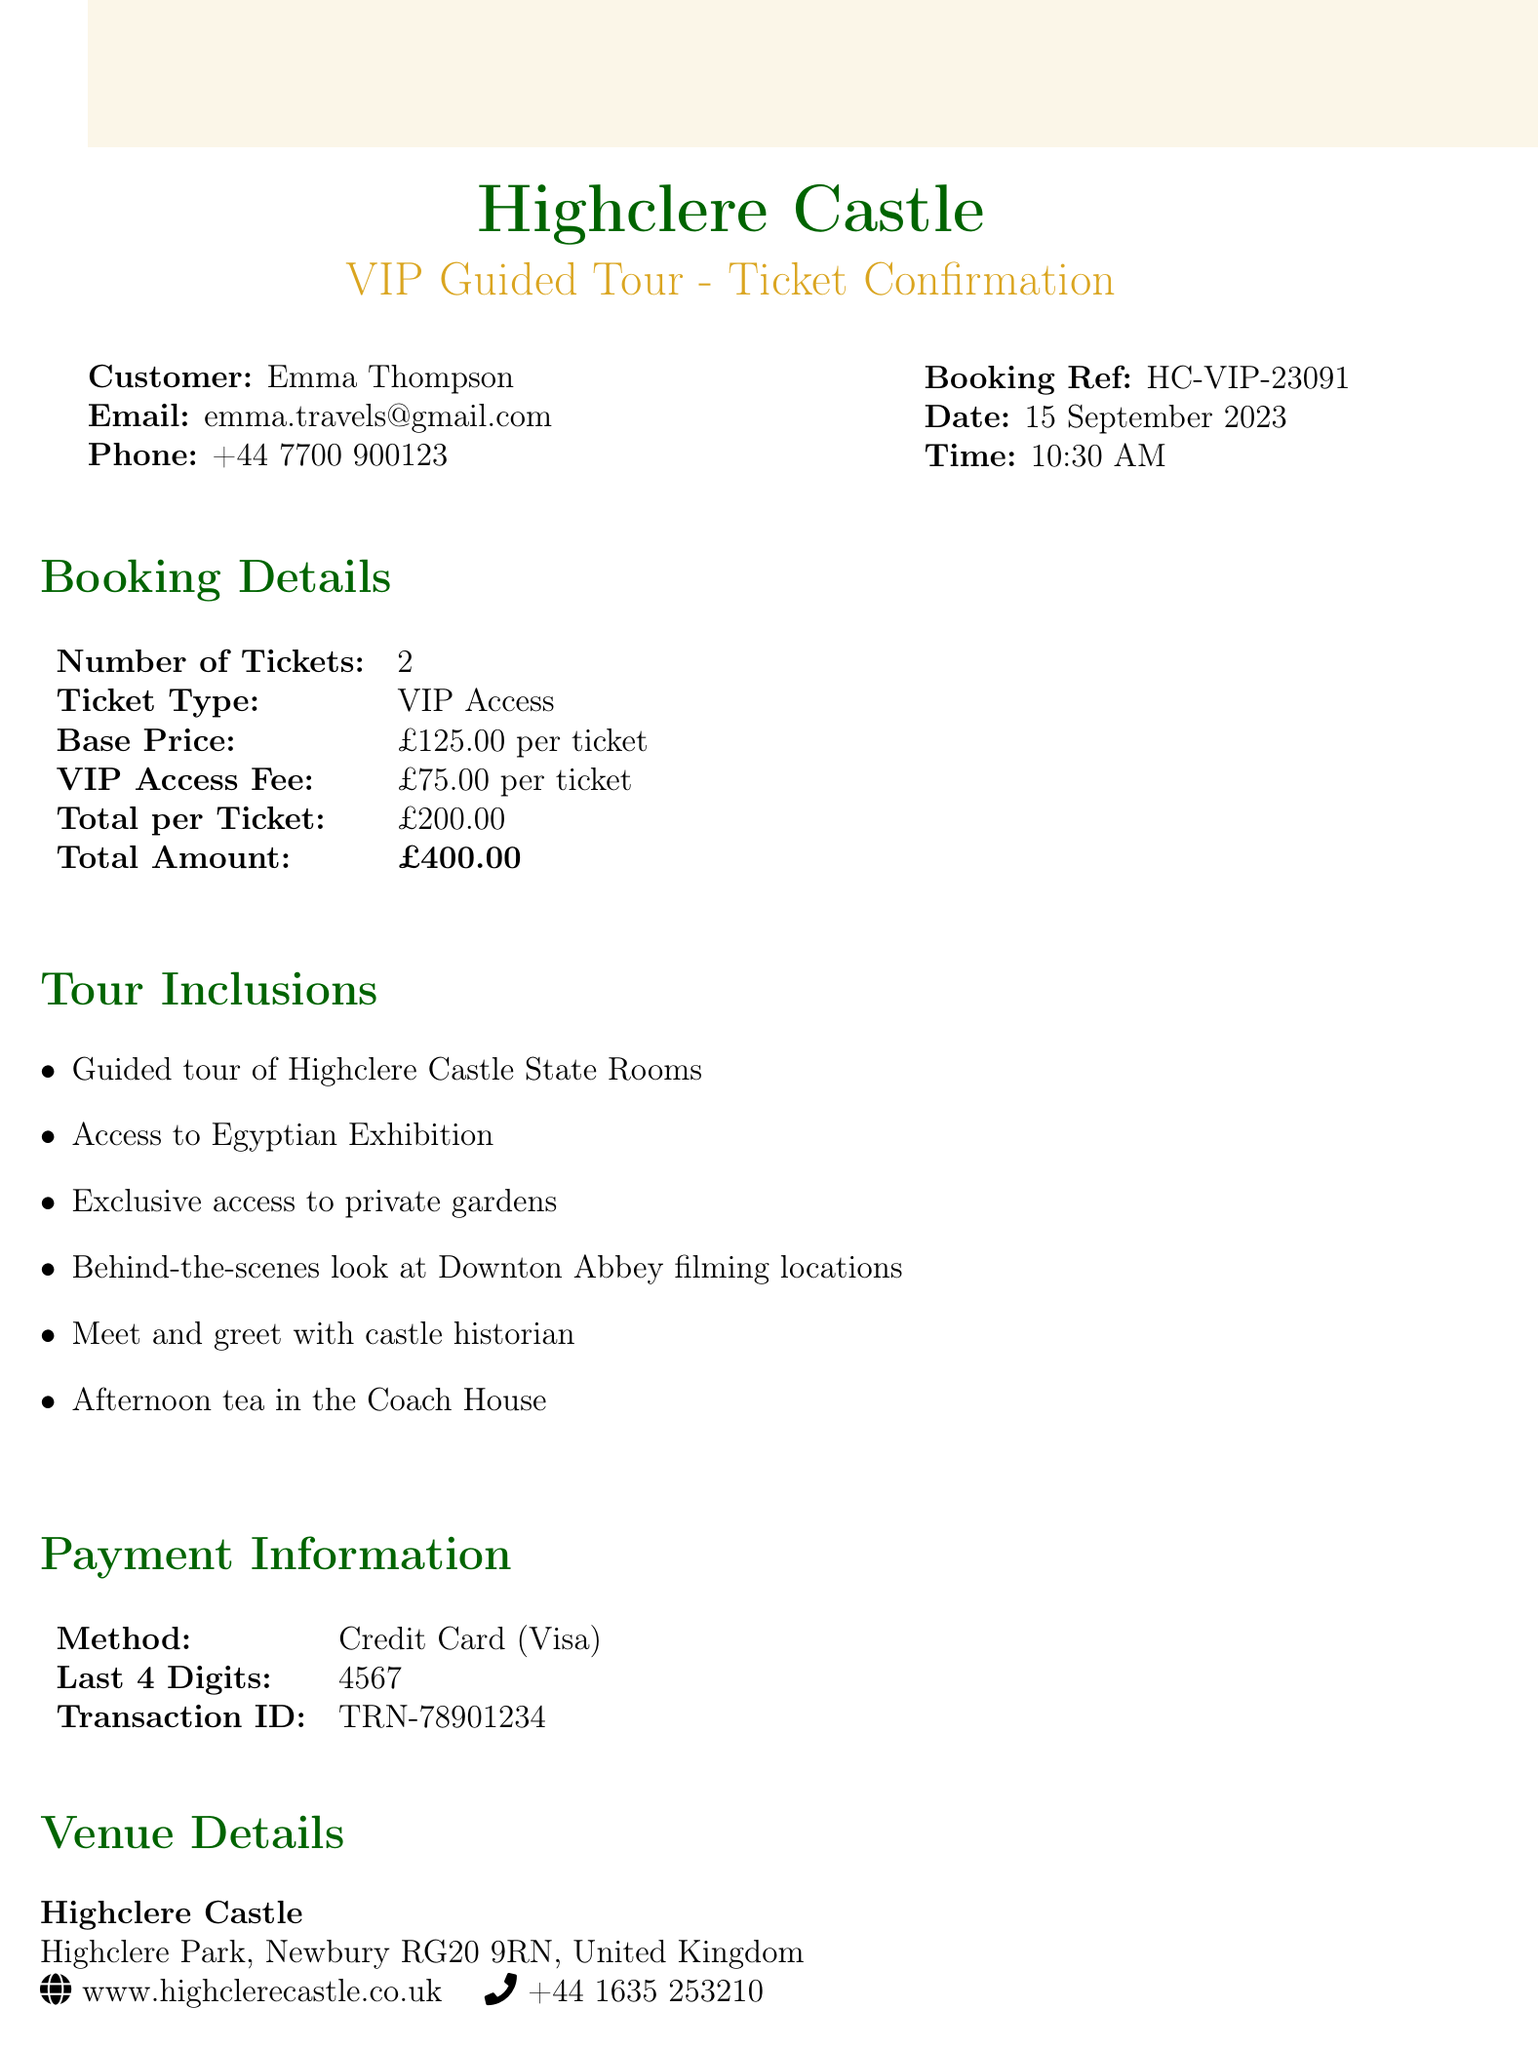What is the event name? The event name is explicitly stated in the document under the section "event_name".
Answer: Guided Tour of Highclere Castle - VIP Access What is the total amount for the tickets? The total amount is provided in the "pricing" section which sums the total costs related to the tickets.
Answer: £400.00 What is the booking reference number? The booking reference number is found in the "booking_details" section under "booking_reference".
Answer: HC-VIP-23091 How many tickets were purchased? The number of tickets is indicated in the "booking_details" section under "number_of_tickets".
Answer: 2 What is the dress code for the tour? The dress code is mentioned in the "additional_info" section highlighting required attire.
Answer: Smart casual What percentage refund is available before 7 days? The percentage is specified in the "cancellation_policy" section detailing refunds based on timing.
Answer: 50 What are the inclusions of the guided tour? The inclusions outline specific experiences offered during the tour, listed under "tour_inclusions".
Answer: Guided tour of Highclere Castle State Rooms, Access to Egyptian Exhibition, Exclusive access to private gardens, Behind-the-scenes look at Downton Abbey filming locations, Meet and greet with castle historian, Afternoon tea in the Coach House Where is the meeting point located? The meeting point is outlined in the "additional_info" section indicating where attendees gather.
Answer: Visitor Centre at Highclere Castle What method was used for payment? The payment method is detailed in the "payment_info" section, specifying how the service was paid for.
Answer: Credit Card 